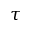Convert formula to latex. <formula><loc_0><loc_0><loc_500><loc_500>\tau</formula> 